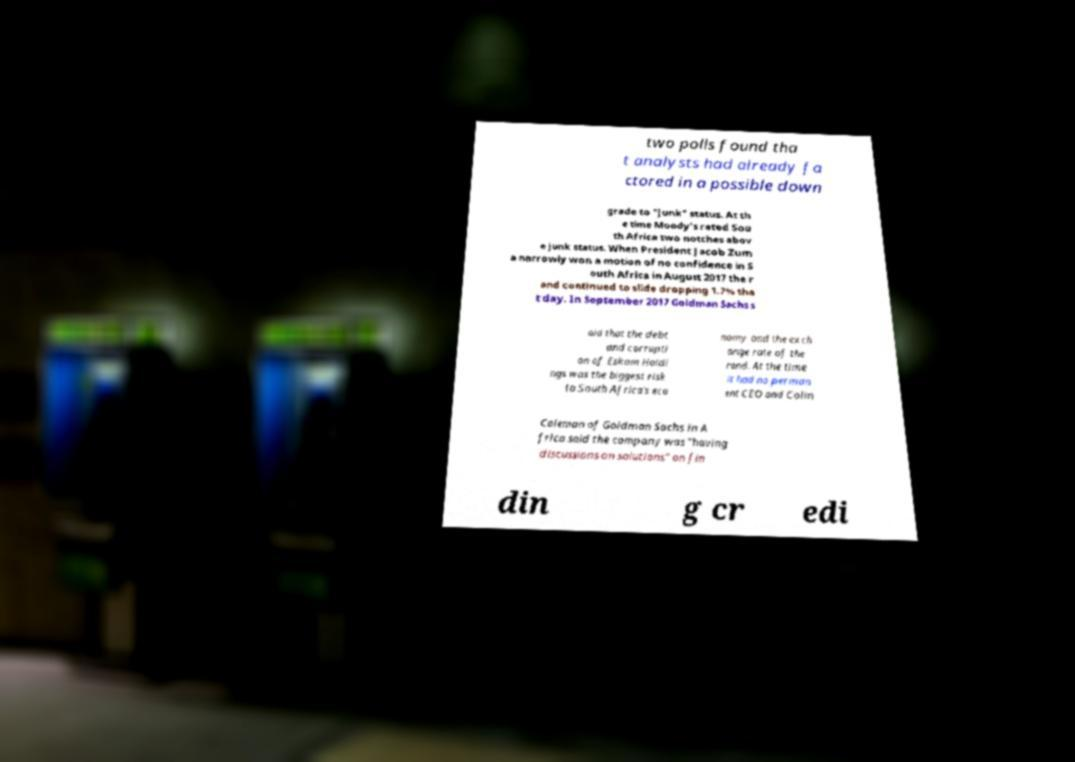For documentation purposes, I need the text within this image transcribed. Could you provide that? two polls found tha t analysts had already fa ctored in a possible down grade to "junk" status. At th e time Moody's rated Sou th Africa two notches abov e junk status. When President Jacob Zum a narrowly won a motion of no confidence in S outh Africa in August 2017 the r and continued to slide dropping 1.7% tha t day. In September 2017 Goldman Sachs s aid that the debt and corrupti on of Eskom Holdi ngs was the biggest risk to South Africa's eco nomy and the exch ange rate of the rand. At the time it had no perman ent CEO and Colin Coleman of Goldman Sachs in A frica said the company was "having discussions on solutions" on fin din g cr edi 